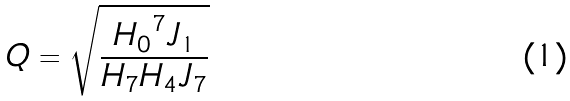<formula> <loc_0><loc_0><loc_500><loc_500>Q = \sqrt { \frac { { H _ { 0 } } ^ { 7 } J _ { 1 } } { H _ { 7 } H _ { 4 } J _ { 7 } } }</formula> 